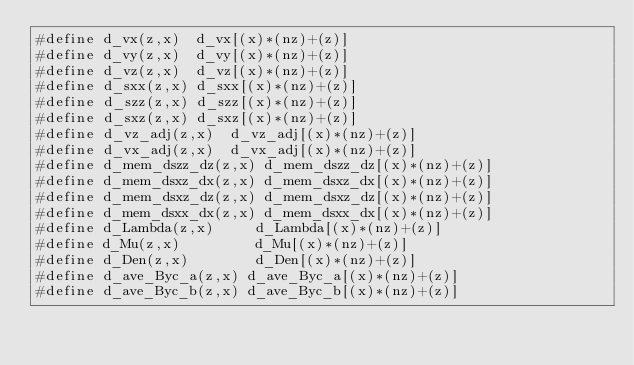<code> <loc_0><loc_0><loc_500><loc_500><_Cuda_>#define d_vx(z,x)  d_vx[(x)*(nz)+(z)]
#define d_vy(z,x)  d_vy[(x)*(nz)+(z)]
#define d_vz(z,x)  d_vz[(x)*(nz)+(z)]
#define d_sxx(z,x) d_sxx[(x)*(nz)+(z)]
#define d_szz(z,x) d_szz[(x)*(nz)+(z)]
#define d_sxz(z,x) d_sxz[(x)*(nz)+(z)]
#define d_vz_adj(z,x)  d_vz_adj[(x)*(nz)+(z)]
#define d_vx_adj(z,x)  d_vx_adj[(x)*(nz)+(z)]
#define d_mem_dszz_dz(z,x) d_mem_dszz_dz[(x)*(nz)+(z)]
#define d_mem_dsxz_dx(z,x) d_mem_dsxz_dx[(x)*(nz)+(z)]
#define d_mem_dsxz_dz(z,x) d_mem_dsxz_dz[(x)*(nz)+(z)]
#define d_mem_dsxx_dx(z,x) d_mem_dsxx_dx[(x)*(nz)+(z)]
#define d_Lambda(z,x)     d_Lambda[(x)*(nz)+(z)]
#define d_Mu(z,x)         d_Mu[(x)*(nz)+(z)]
#define d_Den(z,x)        d_Den[(x)*(nz)+(z)]
#define d_ave_Byc_a(z,x) d_ave_Byc_a[(x)*(nz)+(z)]
#define d_ave_Byc_b(z,x) d_ave_Byc_b[(x)*(nz)+(z)]</code> 